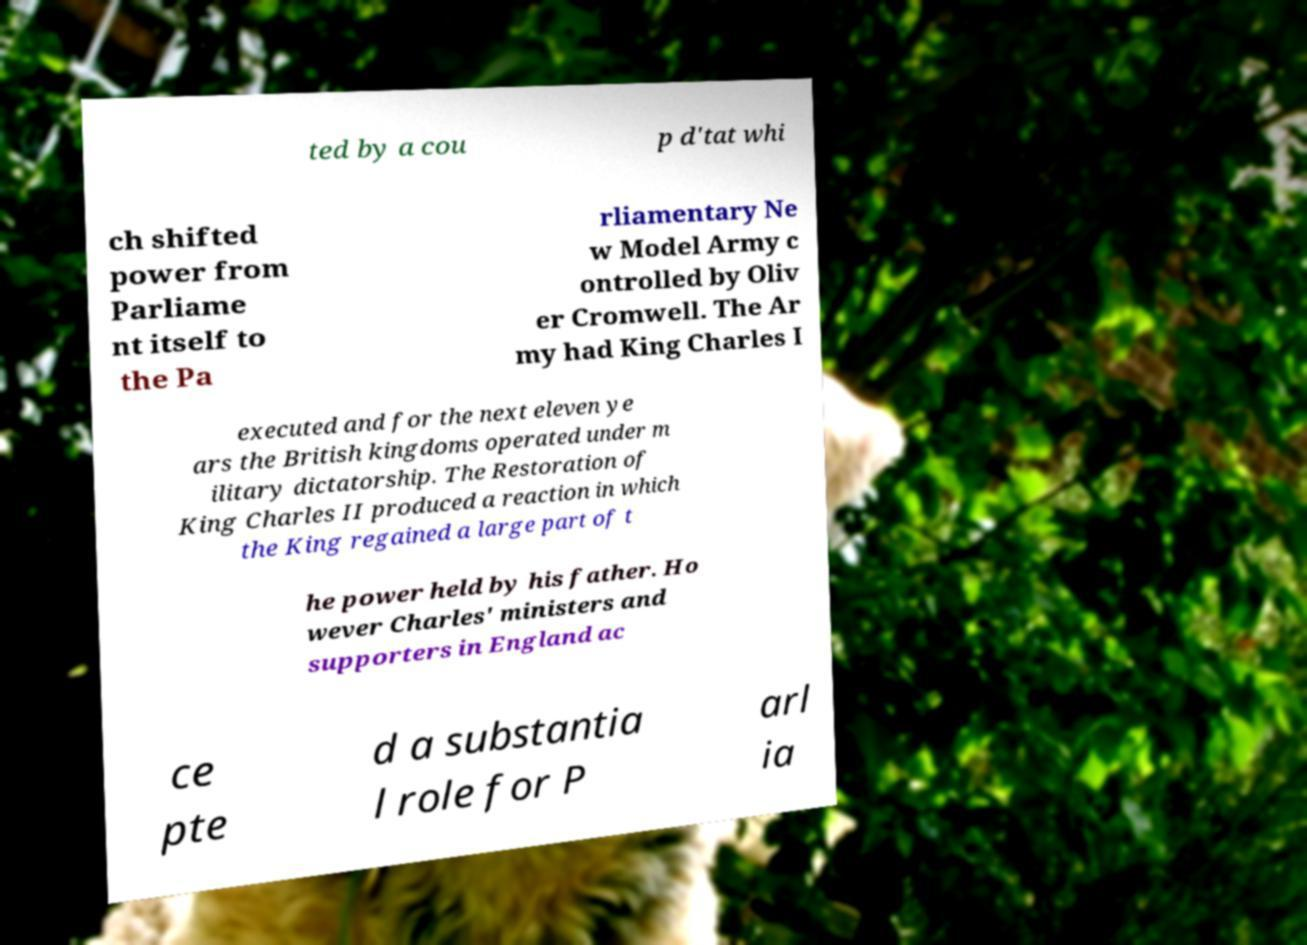Could you assist in decoding the text presented in this image and type it out clearly? ted by a cou p d'tat whi ch shifted power from Parliame nt itself to the Pa rliamentary Ne w Model Army c ontrolled by Oliv er Cromwell. The Ar my had King Charles I executed and for the next eleven ye ars the British kingdoms operated under m ilitary dictatorship. The Restoration of King Charles II produced a reaction in which the King regained a large part of t he power held by his father. Ho wever Charles' ministers and supporters in England ac ce pte d a substantia l role for P arl ia 